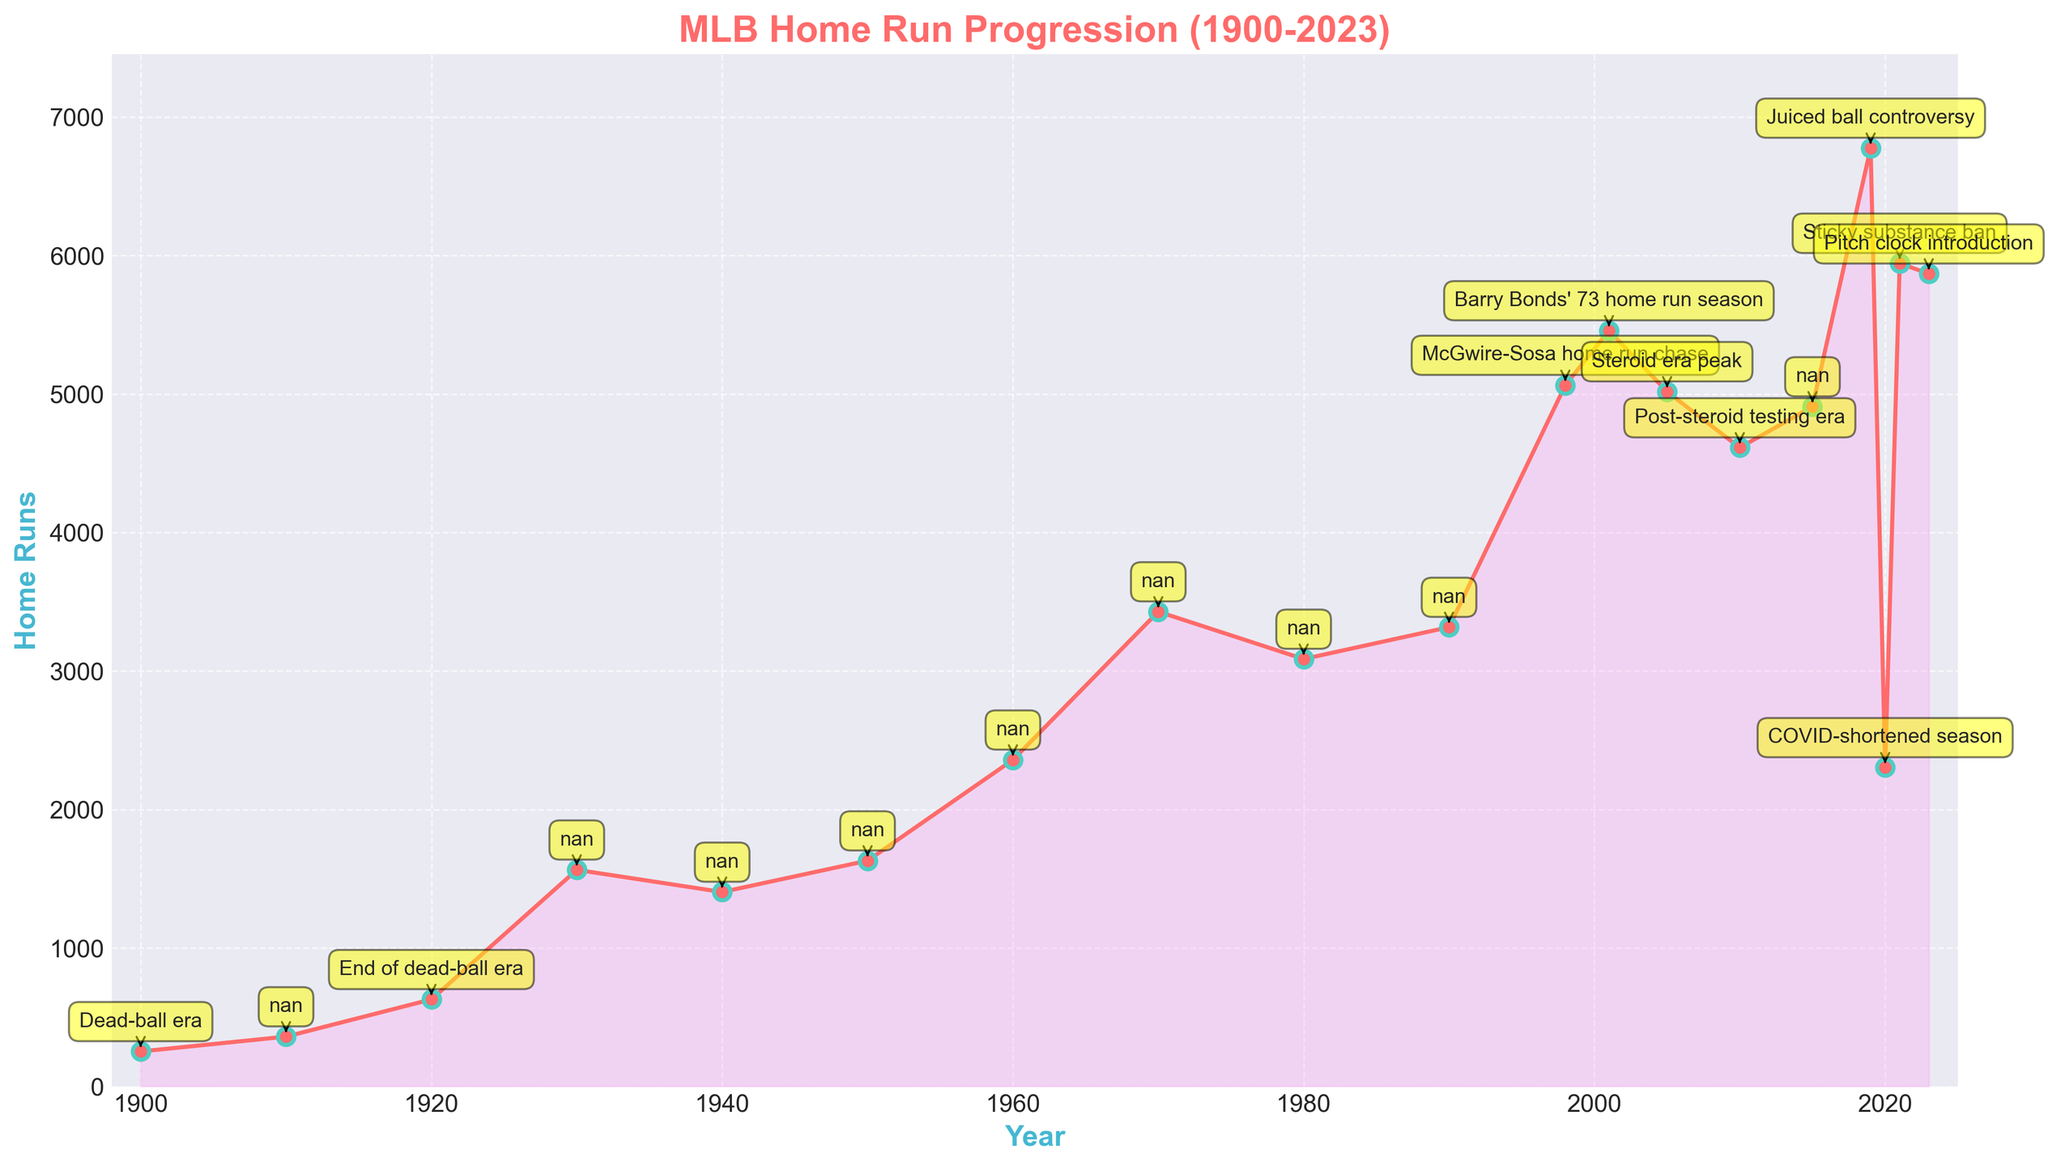What was the home run total in 1998 compared to 2001? The home run total in 1998 was 5064, whereas, in 2001, it was 5458. Comparing these two values: 5458 is greater than 5064.
Answer: The total in 2001 is higher Find the difference in home run totals between the highest year (2019) and the lowest year (1900). The highest home run total is 6776 in 2019, and the lowest is 254 in 1900. The difference between them is 6776 - 254 = 6522.
Answer: 6522 What are the notable events marked between 2000 and 2020? The notable events between 2000 and 2020 are "Barry Bonds’ 73 home run season (2001)", "Steroid era peak (2005)", "Post-steroid testing era (2010)", "Juiced ball controversy (2019)", and "COVID-shortened season (2020)".
Answer: Barry Bonds' 73 HR season, Steroid era peak, Post-steroid testing era, Juiced ball controversy, COVID-shortened season Which period shows a significant drop in home runs and why? The most significant drop is from 2019 to 2020. Home runs went from 6776 to 2304. This is due to the COVID-shortened season.
Answer: 2019 to 2020 due to COVID-shortened season How did the average number of home runs per decade change from the 1980s to the 1990s? Average home runs in the 1980s are 3087, and in the 1990s, it is approximately the average of 3317 (early 1990s value not exact), showing a moderate increase. Comparing 3087 to 3317 shows an average increase.
Answer: Increase What are the peak home run totals during the steroid era compared to the post-steroid testing era? During the steroid era (peak in 2005), the total was 5017. Post-steroid testing era in 2010 was 4613. Comparing 4613 with 5017 shows a decline.
Answer: 5017 during steroid era, 4613 post-steroid testing Identify the change in 2023 relative to the previous year. In 2022, the home run total was not stated, but in 2023, it is 5868. Compared to 5944 in 2021, this shows a slight decrease.
Answer: Decrease When did home runs start to significantly accelerate after the dead-ball era ended? The home run totals accelerated significantly starting from 1930, jumping from 630 in 1920 to 1565.
Answer: 1930 How does the peak of the steroid era (2005) compare to the peak of the juiced ball era (2019)? The steroid era peak in 2005 was 5017, while during the juiced ball era, it was 6776 in 2019, showing an increase.
Answer: 6776 in 2019 is greater Considering the data, did the introduction of the pitch clock in 2023 have a significant impact on home run totals? The home run total in 2023 is 5868. Comparing it to prior years, especially 2021's 5944, the pitch clock introduction seems to have had a minimal impact or slight decrease.
Answer: Minimal impact, slight decrease 